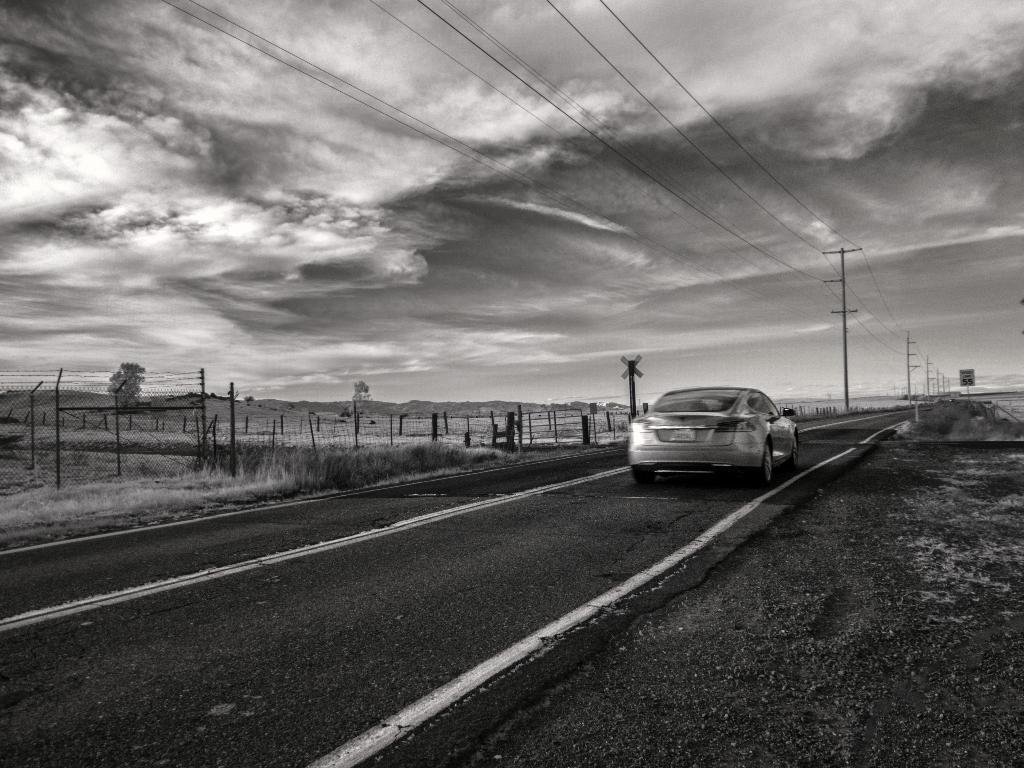In one or two sentences, can you explain what this image depicts? It looks like a black and white picture. We can see a car on the road. In front of the car there is a pole with a board and electrical poles with cables. On the left side of the car there is the fence, grass and the cloudy sky. 